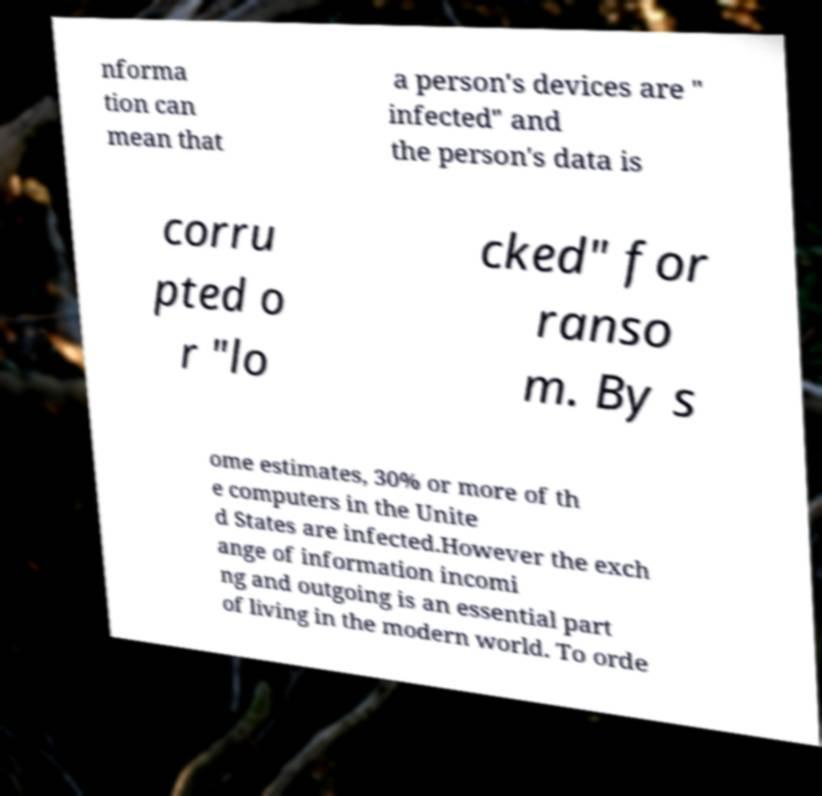What messages or text are displayed in this image? I need them in a readable, typed format. nforma tion can mean that a person's devices are " infected" and the person's data is corru pted o r "lo cked" for ranso m. By s ome estimates, 30% or more of th e computers in the Unite d States are infected.However the exch ange of information incomi ng and outgoing is an essential part of living in the modern world. To orde 